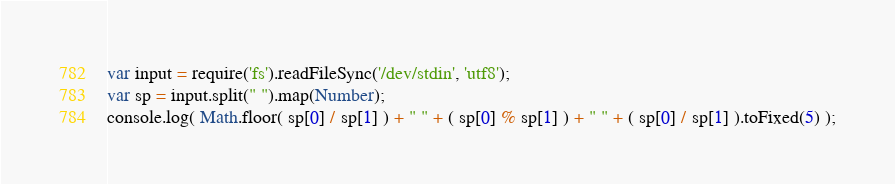Convert code to text. <code><loc_0><loc_0><loc_500><loc_500><_JavaScript_>var input = require('fs').readFileSync('/dev/stdin', 'utf8');
var sp = input.split(" ").map(Number);
console.log( Math.floor( sp[0] / sp[1] ) + " " + ( sp[0] % sp[1] ) + " " + ( sp[0] / sp[1] ).toFixed(5) );</code> 